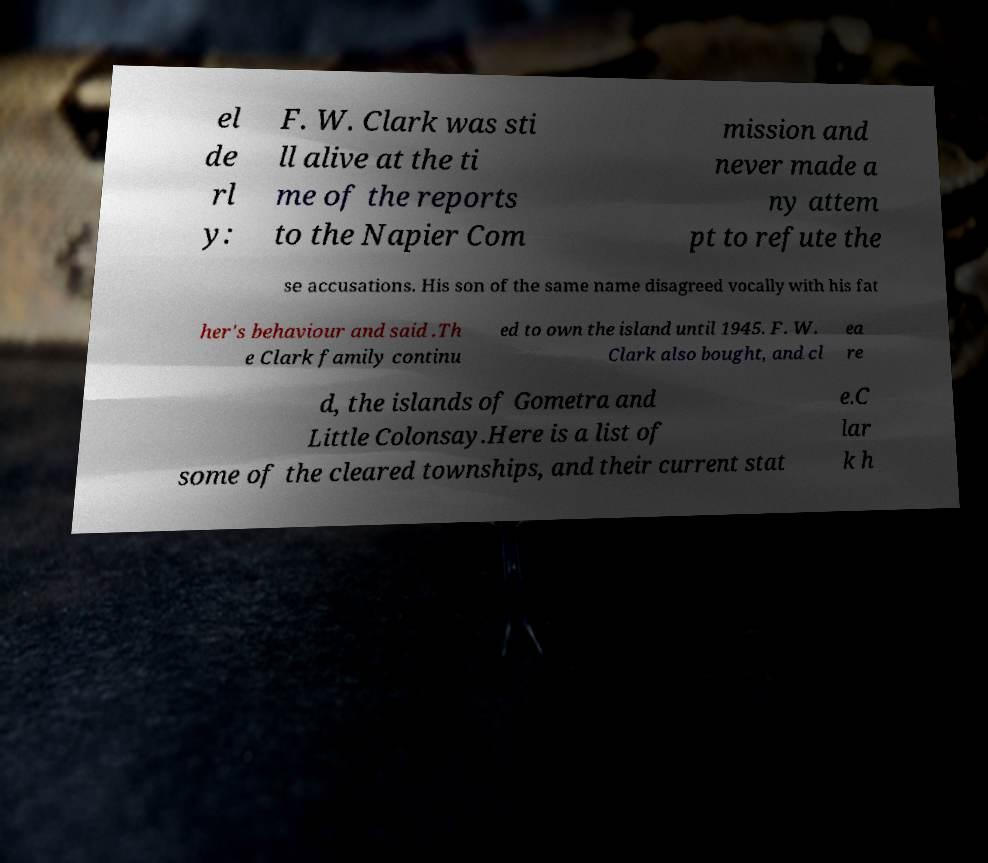There's text embedded in this image that I need extracted. Can you transcribe it verbatim? el de rl y: F. W. Clark was sti ll alive at the ti me of the reports to the Napier Com mission and never made a ny attem pt to refute the se accusations. His son of the same name disagreed vocally with his fat her's behaviour and said .Th e Clark family continu ed to own the island until 1945. F. W. Clark also bought, and cl ea re d, the islands of Gometra and Little Colonsay.Here is a list of some of the cleared townships, and their current stat e.C lar k h 